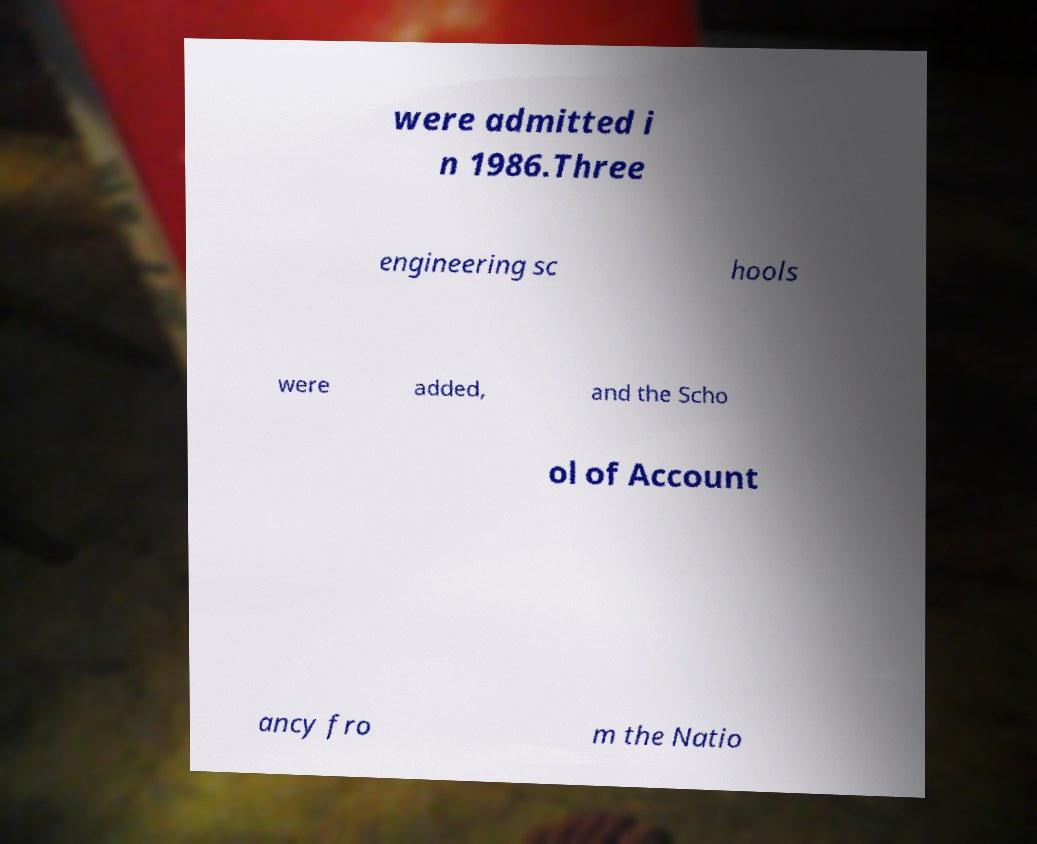I need the written content from this picture converted into text. Can you do that? were admitted i n 1986.Three engineering sc hools were added, and the Scho ol of Account ancy fro m the Natio 